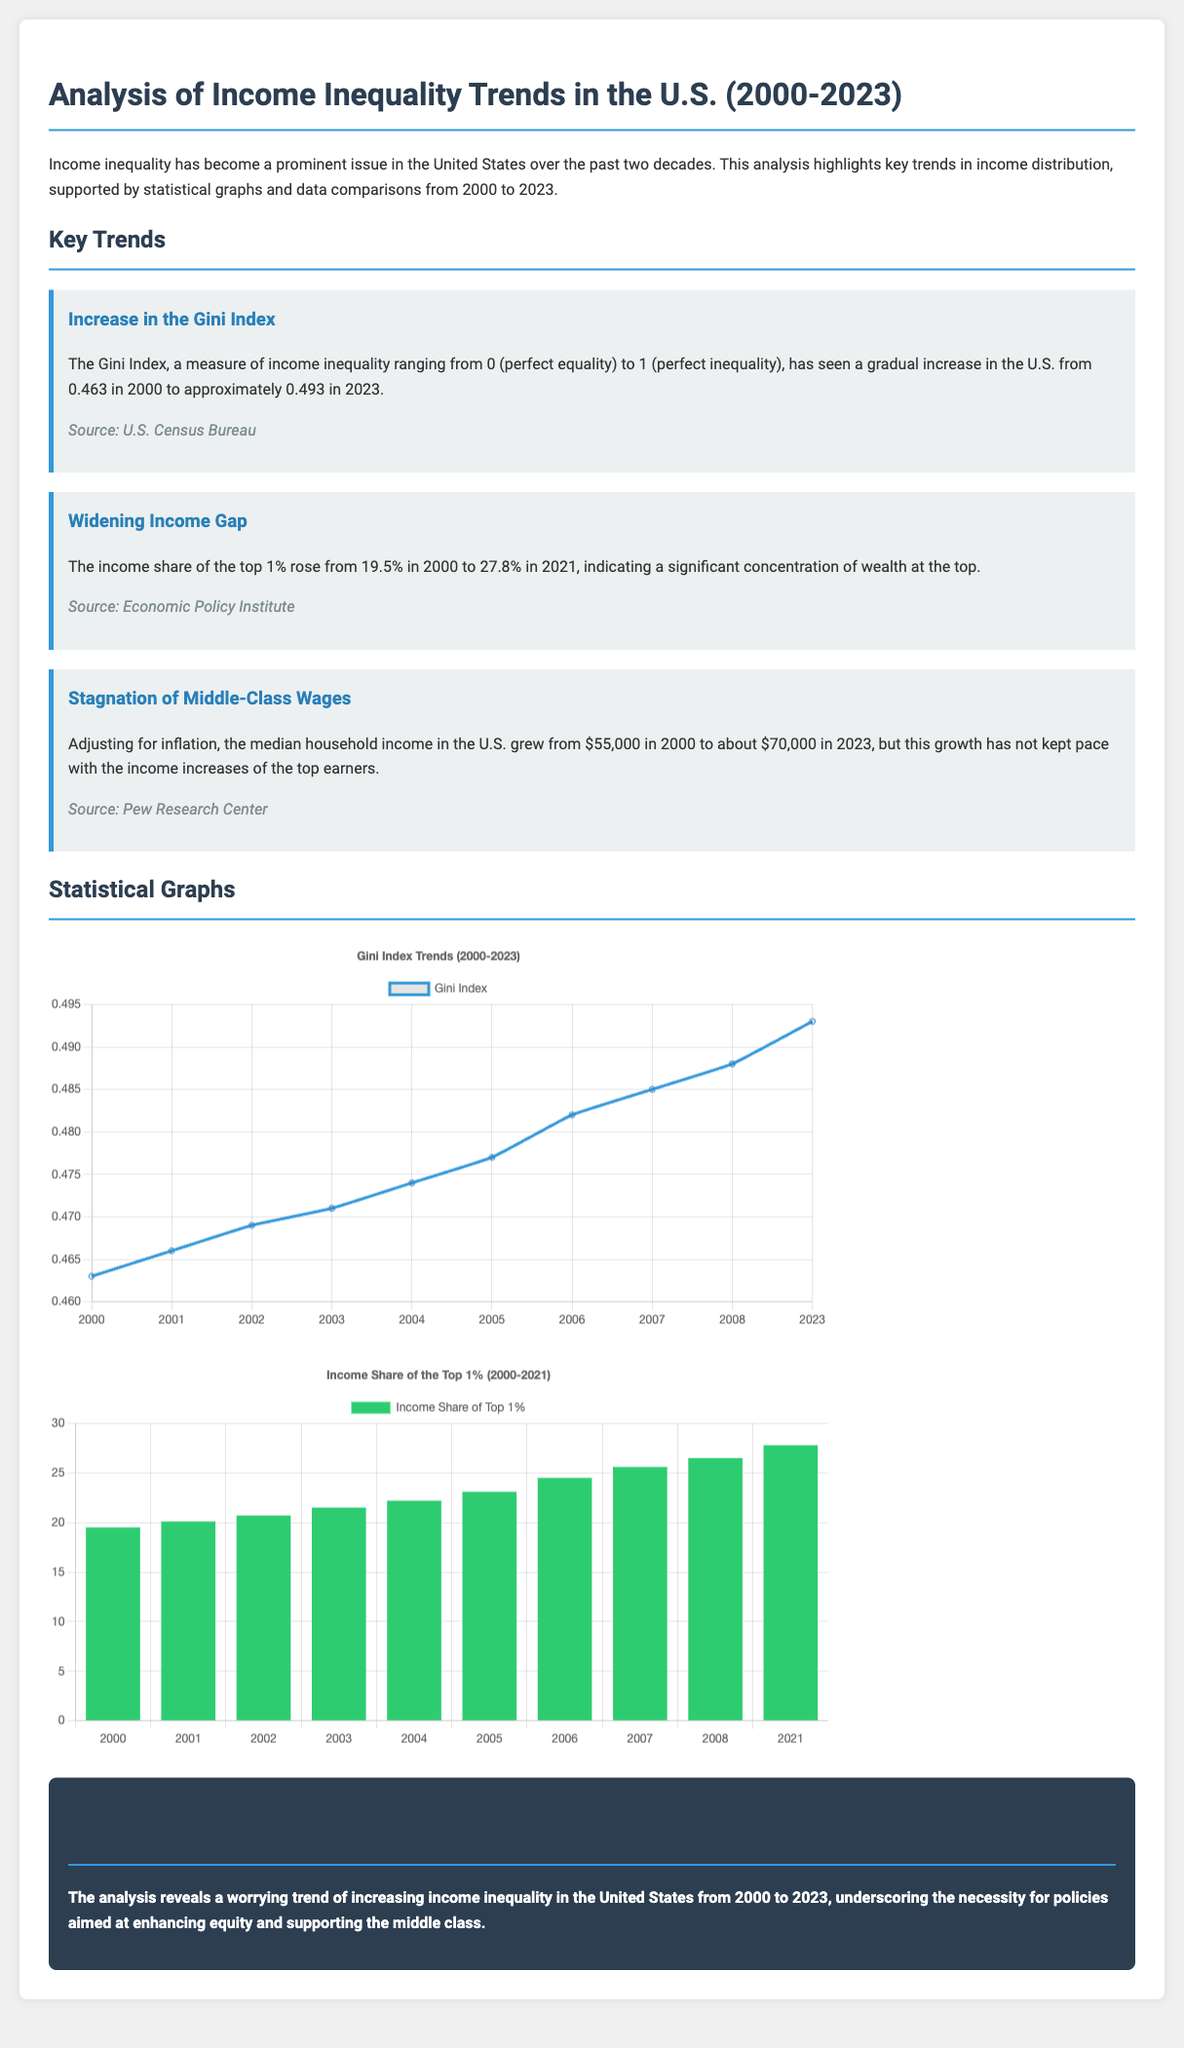What was the Gini Index in 2000? The Gini Index for the year 2000 is mentioned as 0.463 in the document.
Answer: 0.463 What is the Gini Index in 2023? The document states that the Gini Index has increased to approximately 0.493 in 2023.
Answer: 0.493 What percentage of income did the top 1% hold in 2000? The document indicates that the income share of the top 1% was 19.5% in 2000.
Answer: 19.5% What was the income share of the top 1% in 2021? According to the document, the income share of the top 1% rose to 27.8% in 2021.
Answer: 27.8% What was the median household income in 2023? The document notes that the median household income in 2023 is about $70,000.
Answer: $70,000 What is the trend observed in the Gini Index from 2000 to 2023? The document highlights a gradual increase in the Gini Index from the year 2000 to 2023.
Answer: Gradual increase What major issue does the document highlight regarding middle-class wages? The analysis indicates stagnation of middle-class wages relative to the income increases of top earners.
Answer: Stagnation What is the conclusion regarding income inequality trends in the U.S.? The document concludes that there is an increasing trend of income inequality in the U.S. from 2000 to 2023.
Answer: Increasing trend 